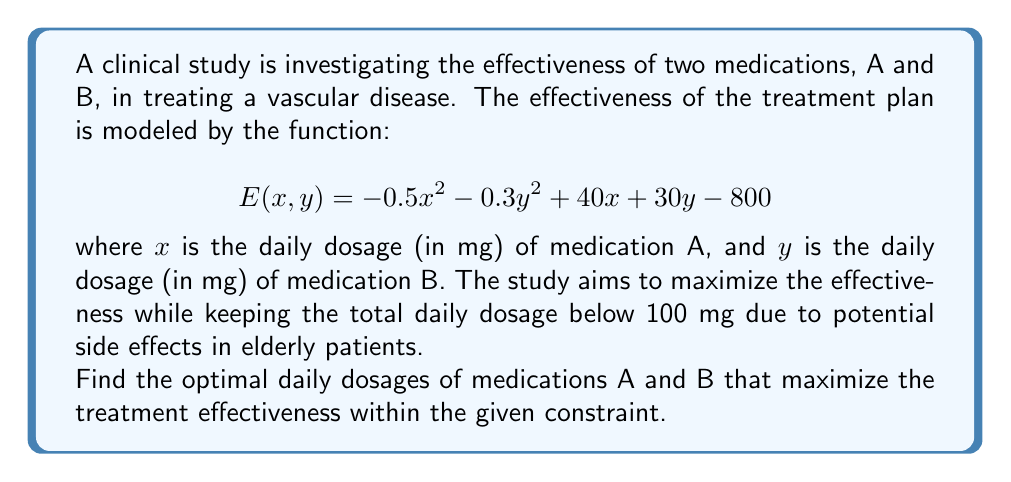Show me your answer to this math problem. To solve this optimization problem with constraints, we'll use the method of Lagrange multipliers.

Step 1: Define the constraint function.
$$g(x, y) = x + y - 100 = 0$$

Step 2: Form the Lagrangian function.
$$L(x, y, λ) = E(x, y) - λg(x, y)$$
$$L(x, y, λ) = -0.5x^2 - 0.3y^2 + 40x + 30y - 800 - λ(x + y - 100)$$

Step 3: Calculate the partial derivatives and set them equal to zero.
$$\frac{\partial L}{\partial x} = -x + 40 - λ = 0$$
$$\frac{\partial L}{\partial y} = -0.6y + 30 - λ = 0$$
$$\frac{\partial L}{\partial λ} = -(x + y - 100) = 0$$

Step 4: Solve the system of equations.
From the first equation: $x = 40 - λ$
From the second equation: $y = 50 - \frac{5}{3}λ$

Substituting these into the third equation:
$$(40 - λ) + (50 - \frac{5}{3}λ) = 100$$
$$90 - \frac{8}{3}λ = 100$$
$$-\frac{8}{3}λ = 10$$
$$λ = -3.75$$

Now we can find $x$ and $y$:
$$x = 40 - (-3.75) = 43.75$$
$$y = 50 - \frac{5}{3}(-3.75) = 56.25$$

Step 5: Verify the constraint is satisfied.
$$43.75 + 56.25 = 100$$

Therefore, the optimal daily dosages are 43.75 mg of medication A and 56.25 mg of medication B.
Answer: Medication A: 43.75 mg, Medication B: 56.25 mg 